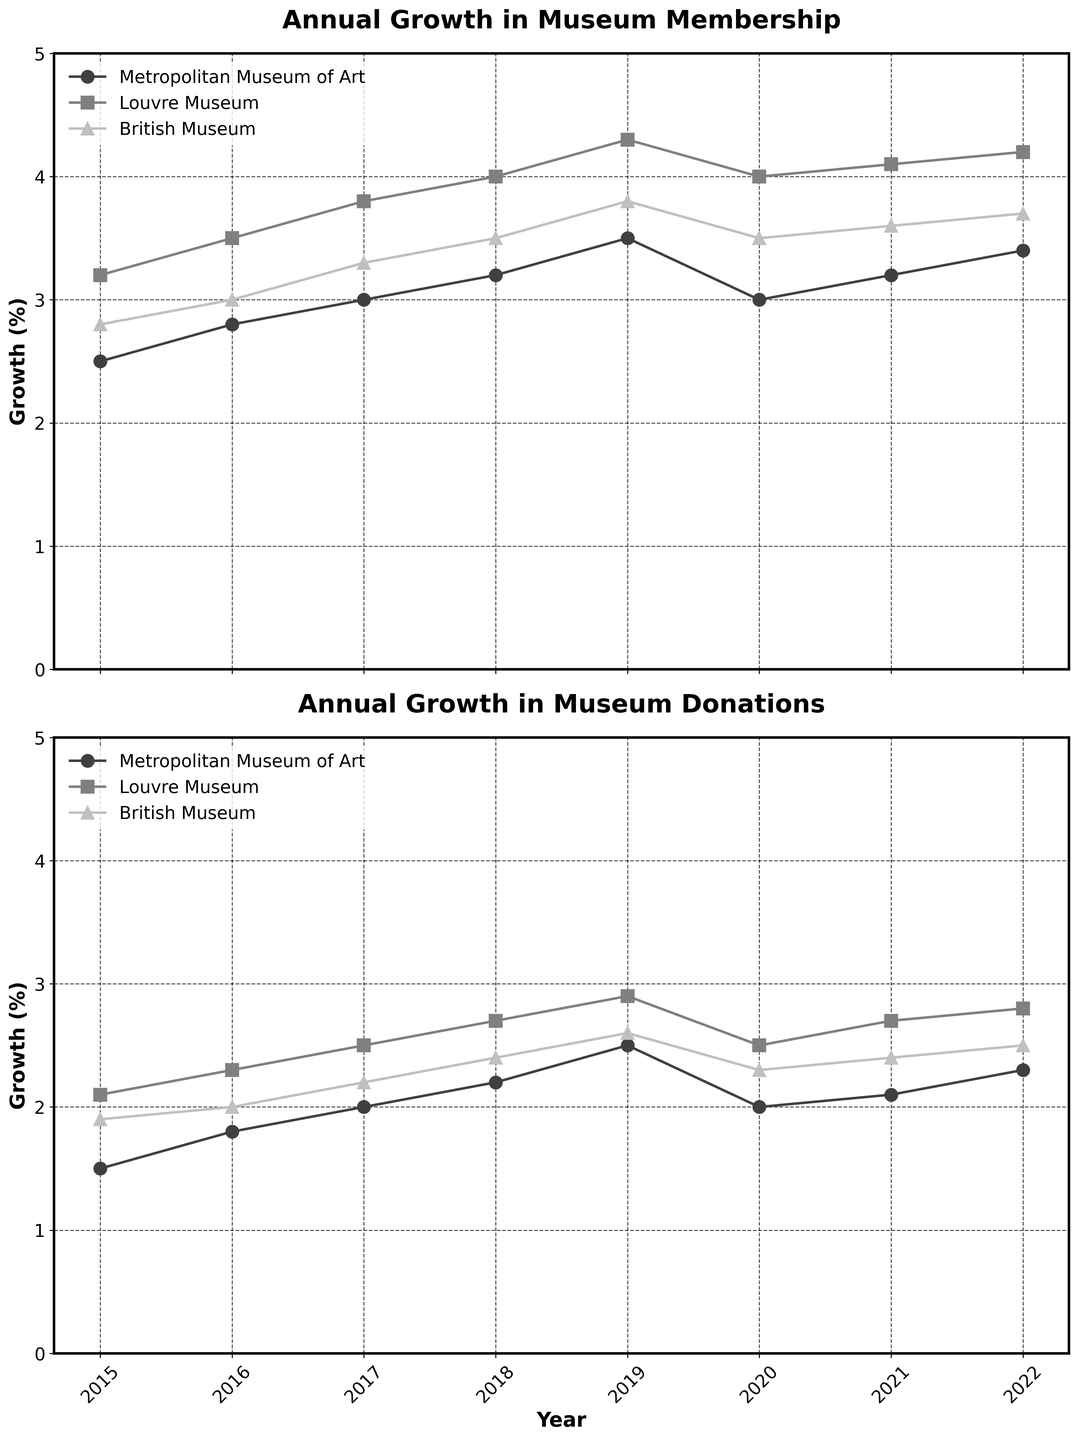What are the titles of the two subplots? The first subplot's title is "Annual Growth in Museum Membership," and the second subplot's title is "Annual Growth in Museum Donations." This information is presented at the top of each subplot in bold text.
Answer: Annual Growth in Museum Membership; Annual Growth in Museum Donations Which museum had the highest membership growth in 2022? To find the highest membership growth in 2022, look at the last data point in the legend for each museum. In 2022, the Louvre Museum had the highest membership growth at 4.2%.
Answer: Louvre Museum What is the donation growth percentage for the British Museum in 2019? Locate the British Museum's donation data series and find the value for the year 2019. It is 2.6%, which is marked on the plot by a gray triangle.
Answer: 2.6% How did the membership growth of the Metropolitan Museum of Art change from 2019 to 2020? Identify the membership growth values for the Metropolitan Museum of Art in 2019 and 2020. In 2019, it was 3.5%, and in 2020, it decreased to 3.0%. Hence, the change is a decrease of 0.5%.
Answer: Decreased by 0.5% What is the average donation growth percentage for the Louvre Museum between 2015 and 2022? To calculate the average, sum the donation growth percentages for the Louvre Museum from 2015 to 2022, then divide by the number of years: (2.1 + 2.3 + 2.5 + 2.7 + 2.9 + 2.5 + 2.7 + 2.8) / 8 = 20.5 / 8 = 2.56.
Answer: 2.56% Which museum showed the smallest variation in donation growth between 2015 and 2022? By observing the donation growth lines across the plots, the British Museum has the smallest variation as its line appears the most stable, with growth ranging between 1.9% and 2.6%.
Answer: British Museum Comparing the membership growth in 2018, which museum had the highest and which the lowest? In 2018, locate the membership growth values for all three museums. The Louvre Museum had the highest at 4.0%, and the British Museum had the lowest at 3.5%.
Answer: Louvre Museum highest; British Museum lowest By how much did the donation growth for the Metropolitan Museum of Art increase from 2015 to 2019? Locate the donation growth values for the Metropolitan Museum of Art in 2015 (1.5%) and in 2019 (2.5%). The increase is calculated as 2.5% - 1.5% = 1.0%.
Answer: 1.0% What trend is observed for the Louvre Museum’s membership growth between 2015 and 2019? From 2015 to 2019, observe the line for the Louvre Museum in the membership growth plot. The line shows a gradual upward trend, increasing from 3.2% to 4.3%.
Answer: Upward trend 